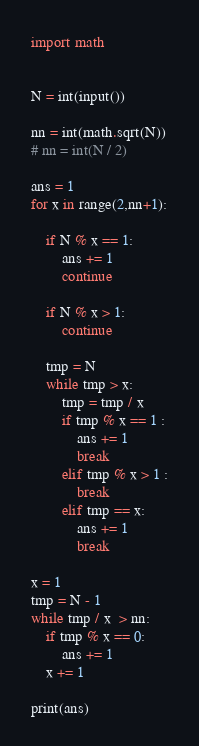Convert code to text. <code><loc_0><loc_0><loc_500><loc_500><_Python_>import math


N = int(input())

nn = int(math.sqrt(N))
# nn = int(N / 2)

ans = 1
for x in range(2,nn+1):

    if N % x == 1:
        ans += 1
        continue
    
    if N % x > 1:
        continue

    tmp = N
    while tmp > x:
        tmp = tmp / x
        if tmp % x == 1 :
            ans += 1
            break
        elif tmp % x > 1 :
            break
        elif tmp == x:
            ans += 1
            break

x = 1
tmp = N - 1
while tmp / x  > nn:
    if tmp % x == 0:
        ans += 1
    x += 1

print(ans)
</code> 